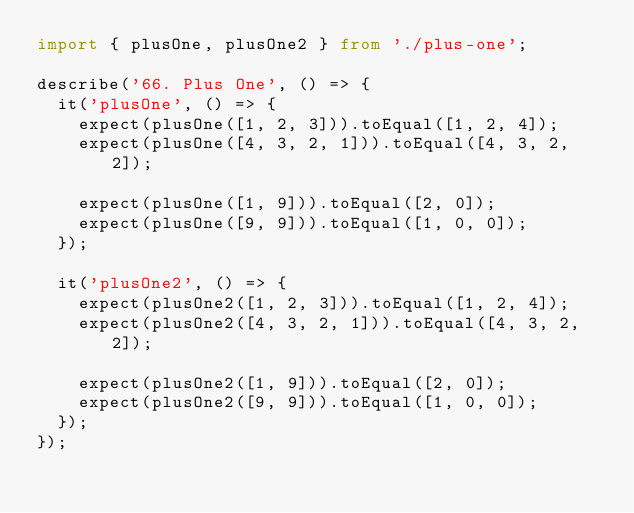<code> <loc_0><loc_0><loc_500><loc_500><_TypeScript_>import { plusOne, plusOne2 } from './plus-one';

describe('66. Plus One', () => {
  it('plusOne', () => {
    expect(plusOne([1, 2, 3])).toEqual([1, 2, 4]);
    expect(plusOne([4, 3, 2, 1])).toEqual([4, 3, 2, 2]);

    expect(plusOne([1, 9])).toEqual([2, 0]);
    expect(plusOne([9, 9])).toEqual([1, 0, 0]);
  });

  it('plusOne2', () => {
    expect(plusOne2([1, 2, 3])).toEqual([1, 2, 4]);
    expect(plusOne2([4, 3, 2, 1])).toEqual([4, 3, 2, 2]);

    expect(plusOne2([1, 9])).toEqual([2, 0]);
    expect(plusOne2([9, 9])).toEqual([1, 0, 0]);
  });
});
</code> 